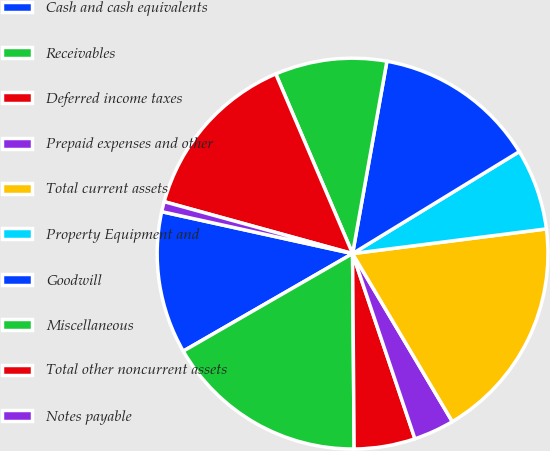Convert chart to OTSL. <chart><loc_0><loc_0><loc_500><loc_500><pie_chart><fcel>Cash and cash equivalents<fcel>Receivables<fcel>Deferred income taxes<fcel>Prepaid expenses and other<fcel>Total current assets<fcel>Property Equipment and<fcel>Goodwill<fcel>Miscellaneous<fcel>Total other noncurrent assets<fcel>Notes payable<nl><fcel>11.76%<fcel>16.81%<fcel>5.04%<fcel>3.36%<fcel>18.49%<fcel>6.72%<fcel>13.45%<fcel>9.24%<fcel>14.29%<fcel>0.84%<nl></chart> 